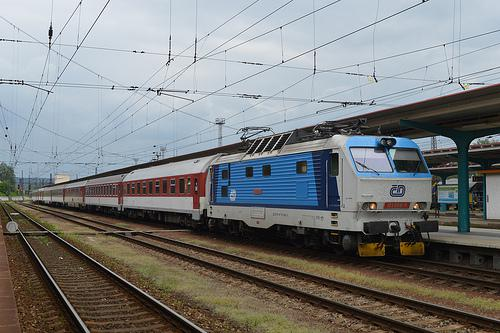Question: what do trains roll on?
Choices:
A. Wheels.
B. Pistons.
C. Power.
D. Tracks.
Answer with the letter. Answer: D Question: what color is the sky?
Choices:
A. Grey.
B. Blue.
C. White.
D. Black.
Answer with the letter. Answer: B Question: who drives a train?
Choices:
A. A man.
B. A woman.
C. Engineer.
D. A railroad employee.
Answer with the letter. Answer: C Question: when do guardrails go down at railroad crossings?
Choices:
A. When cars approach the moving train.
B. In towns.
C. When train is near.
D. When they sense the train approaching.
Answer with the letter. Answer: C 